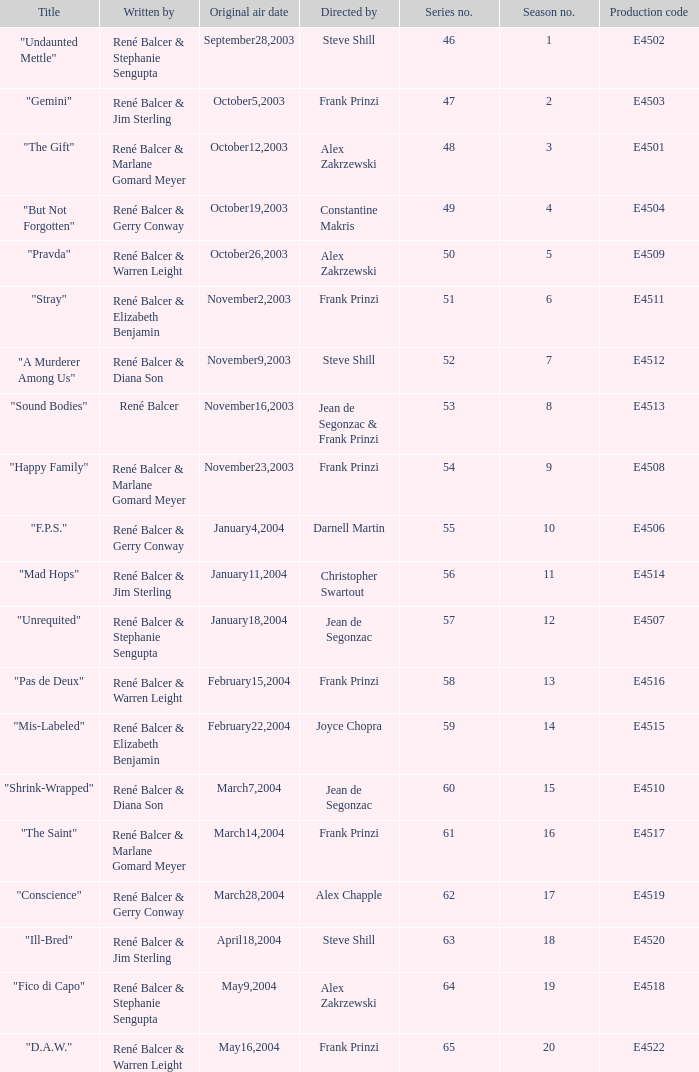Can you give me this table as a dict? {'header': ['Title', 'Written by', 'Original air date', 'Directed by', 'Series no.', 'Season no.', 'Production code'], 'rows': [['"Undaunted Mettle"', 'René Balcer & Stephanie Sengupta', 'September28,2003', 'Steve Shill', '46', '1', 'E4502'], ['"Gemini"', 'René Balcer & Jim Sterling', 'October5,2003', 'Frank Prinzi', '47', '2', 'E4503'], ['"The Gift"', 'René Balcer & Marlane Gomard Meyer', 'October12,2003', 'Alex Zakrzewski', '48', '3', 'E4501'], ['"But Not Forgotten"', 'René Balcer & Gerry Conway', 'October19,2003', 'Constantine Makris', '49', '4', 'E4504'], ['"Pravda"', 'René Balcer & Warren Leight', 'October26,2003', 'Alex Zakrzewski', '50', '5', 'E4509'], ['"Stray"', 'René Balcer & Elizabeth Benjamin', 'November2,2003', 'Frank Prinzi', '51', '6', 'E4511'], ['"A Murderer Among Us"', 'René Balcer & Diana Son', 'November9,2003', 'Steve Shill', '52', '7', 'E4512'], ['"Sound Bodies"', 'René Balcer', 'November16,2003', 'Jean de Segonzac & Frank Prinzi', '53', '8', 'E4513'], ['"Happy Family"', 'René Balcer & Marlane Gomard Meyer', 'November23,2003', 'Frank Prinzi', '54', '9', 'E4508'], ['"F.P.S."', 'René Balcer & Gerry Conway', 'January4,2004', 'Darnell Martin', '55', '10', 'E4506'], ['"Mad Hops"', 'René Balcer & Jim Sterling', 'January11,2004', 'Christopher Swartout', '56', '11', 'E4514'], ['"Unrequited"', 'René Balcer & Stephanie Sengupta', 'January18,2004', 'Jean de Segonzac', '57', '12', 'E4507'], ['"Pas de Deux"', 'René Balcer & Warren Leight', 'February15,2004', 'Frank Prinzi', '58', '13', 'E4516'], ['"Mis-Labeled"', 'René Balcer & Elizabeth Benjamin', 'February22,2004', 'Joyce Chopra', '59', '14', 'E4515'], ['"Shrink-Wrapped"', 'René Balcer & Diana Son', 'March7,2004', 'Jean de Segonzac', '60', '15', 'E4510'], ['"The Saint"', 'René Balcer & Marlane Gomard Meyer', 'March14,2004', 'Frank Prinzi', '61', '16', 'E4517'], ['"Conscience"', 'René Balcer & Gerry Conway', 'March28,2004', 'Alex Chapple', '62', '17', 'E4519'], ['"Ill-Bred"', 'René Balcer & Jim Sterling', 'April18,2004', 'Steve Shill', '63', '18', 'E4520'], ['"Fico di Capo"', 'René Balcer & Stephanie Sengupta', 'May9,2004', 'Alex Zakrzewski', '64', '19', 'E4518'], ['"D.A.W."', 'René Balcer & Warren Leight', 'May16,2004', 'Frank Prinzi', '65', '20', 'E4522']]} Who wrote the episode with e4515 as the production code? René Balcer & Elizabeth Benjamin. 